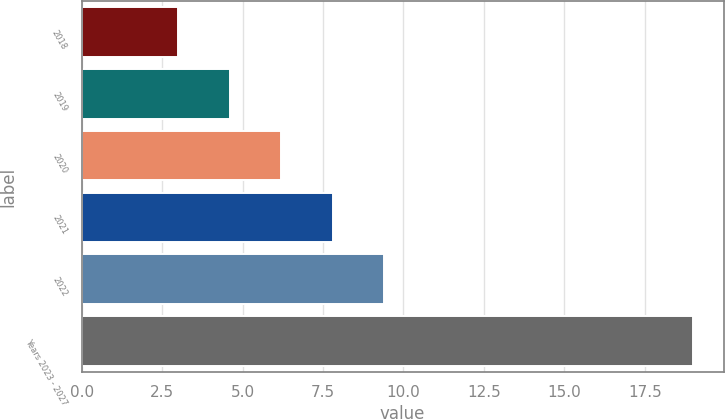<chart> <loc_0><loc_0><loc_500><loc_500><bar_chart><fcel>2018<fcel>2019<fcel>2020<fcel>2021<fcel>2022<fcel>Years 2023 - 2027<nl><fcel>3<fcel>4.6<fcel>6.2<fcel>7.8<fcel>9.4<fcel>19<nl></chart> 